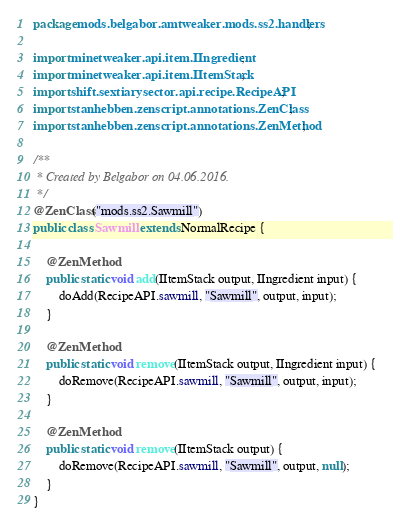Convert code to text. <code><loc_0><loc_0><loc_500><loc_500><_Java_>package mods.belgabor.amtweaker.mods.ss2.handlers;

import minetweaker.api.item.IIngredient;
import minetweaker.api.item.IItemStack;
import shift.sextiarysector.api.recipe.RecipeAPI;
import stanhebben.zenscript.annotations.ZenClass;
import stanhebben.zenscript.annotations.ZenMethod;

/**
 * Created by Belgabor on 04.06.2016.
 */
@ZenClass("mods.ss2.Sawmill")
public class Sawmill extends NormalRecipe {
    
    @ZenMethod
    public static void add(IItemStack output, IIngredient input) {
        doAdd(RecipeAPI.sawmill, "Sawmill", output, input);
    }
    
    @ZenMethod
    public static void remove(IItemStack output, IIngredient input) {
        doRemove(RecipeAPI.sawmill, "Sawmill", output, input);
    }
    
    @ZenMethod
    public static void remove(IItemStack output) {
        doRemove(RecipeAPI.sawmill, "Sawmill", output, null);
    }
}
</code> 